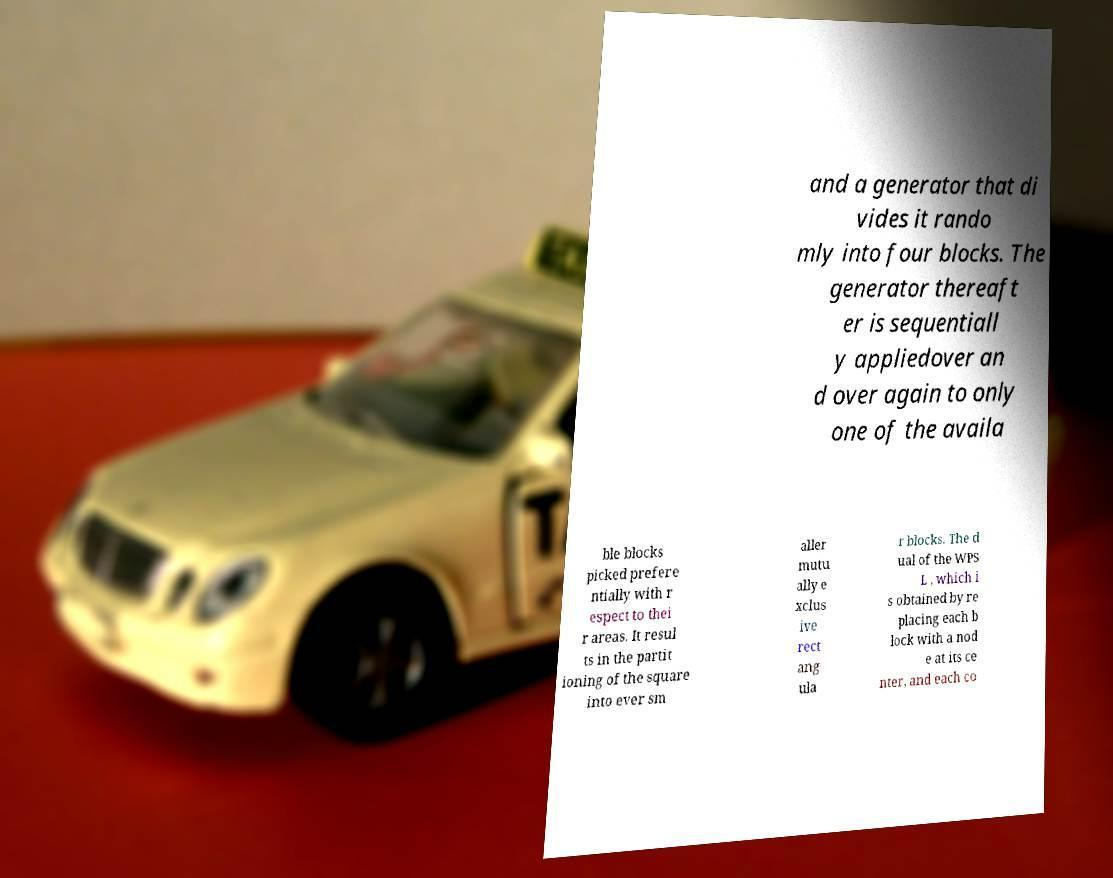Can you accurately transcribe the text from the provided image for me? and a generator that di vides it rando mly into four blocks. The generator thereaft er is sequentiall y appliedover an d over again to only one of the availa ble blocks picked prefere ntially with r espect to thei r areas. It resul ts in the partit ioning of the square into ever sm aller mutu ally e xclus ive rect ang ula r blocks. The d ual of the WPS L , which i s obtained by re placing each b lock with a nod e at its ce nter, and each co 